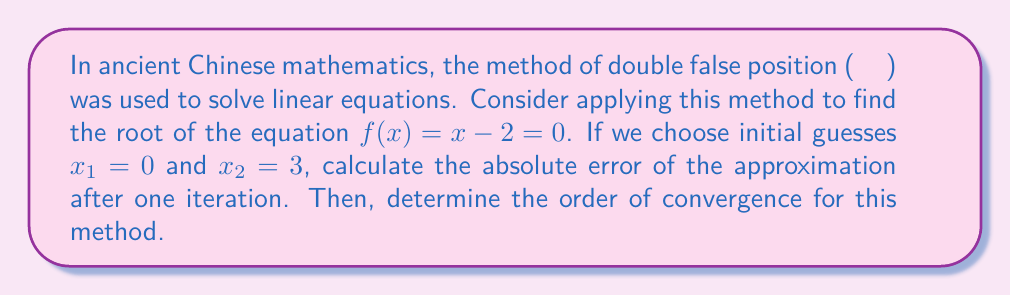Give your solution to this math problem. Let's approach this problem step by step:

1) The method of double false position (also known as Regula Falsi) uses the following formula to generate the next approximation:

   $$x_{n+1} = x_n - f(x_n) \frac{x_n - x_{n-1}}{f(x_n) - f(x_{n-1})}$$

2) We have $f(x) = x - 2$, and our initial guesses are $x_1 = 0$ and $x_2 = 3$. Let's calculate $f(x_1)$ and $f(x_2)$:

   $$f(x_1) = f(0) = 0 - 2 = -2$$
   $$f(x_2) = f(3) = 3 - 2 = 1$$

3) Now, let's apply the formula to find $x_3$:

   $$x_3 = 3 - 1 \cdot \frac{3 - 0}{1 - (-2)} = 3 - \frac{3}{3} = 2$$

4) The true root of the equation is 2, so our approximation $x_3 = 2$ is exact.

5) The absolute error is defined as $|x - x^*|$, where $x$ is the approximation and $x^*$ is the true value. In this case:

   $$\text{Absolute Error} = |2 - 2| = 0$$

6) To determine the order of convergence, we need to analyze how quickly the error decreases. In this case, we achieved the exact solution in one iteration, which is not typical for the Regula Falsi method.

7) In general, the Regula Falsi method has a convergence order of approximately 1.618 (the golden ratio), which is superlinear but not quite quadratic.
Answer: The absolute error after one iteration is 0. The order of convergence for the Regula Falsi method is approximately 1.618. 